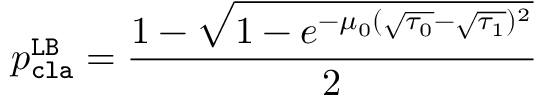<formula> <loc_0><loc_0><loc_500><loc_500>p _ { c l a } ^ { L B } = \frac { 1 - \sqrt { 1 - e ^ { - \mu _ { 0 } ( \sqrt { \tau _ { 0 } } - \sqrt { \tau _ { 1 } } ) ^ { 2 } } } } { 2 }</formula> 